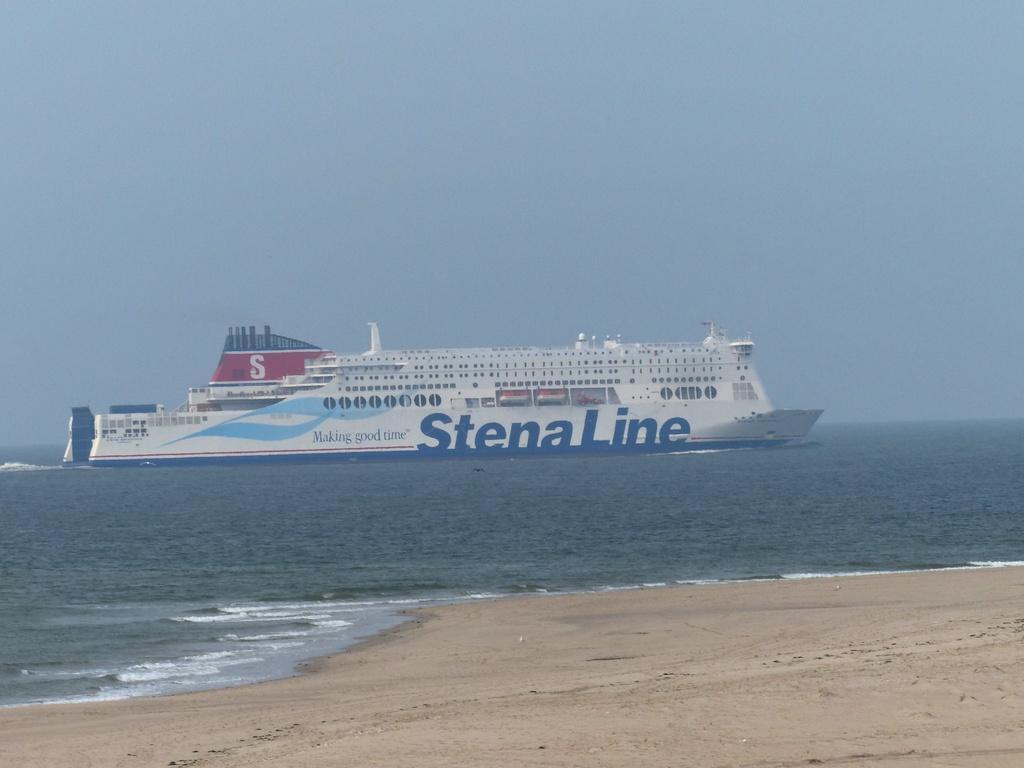Please provide a concise description of this image. There is a ship in the water. On the ship there is something written. Also there is sand in the front. In the background there is sky. 